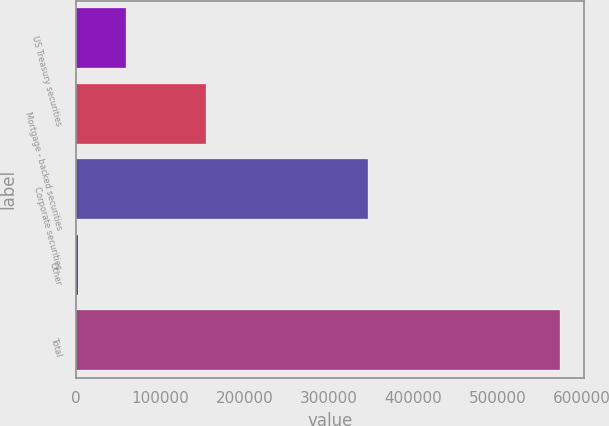Convert chart. <chart><loc_0><loc_0><loc_500><loc_500><bar_chart><fcel>US Treasury securities<fcel>Mortgage - backed securities<fcel>Corporate securities<fcel>Other<fcel>Total<nl><fcel>59718.7<fcel>153835<fcel>347052<fcel>2579<fcel>573976<nl></chart> 